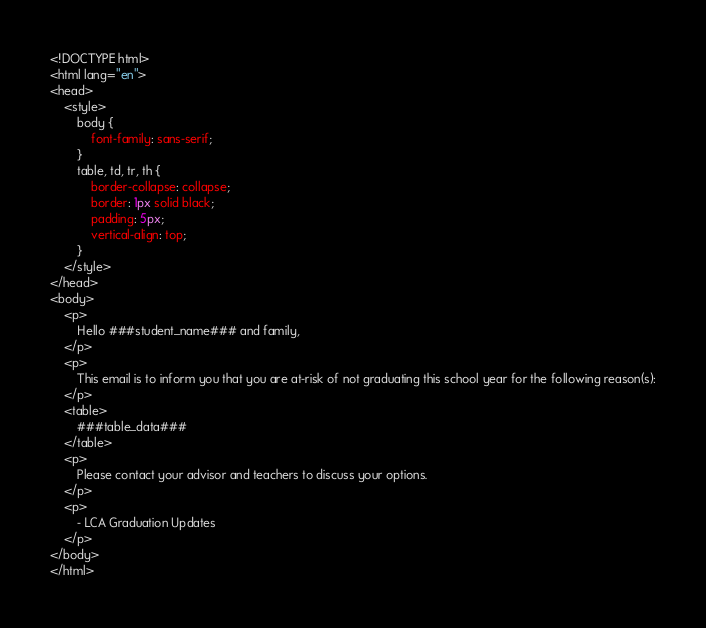Convert code to text. <code><loc_0><loc_0><loc_500><loc_500><_HTML_><!DOCTYPE html>
<html lang="en">
<head>
    <style>
        body {
            font-family: sans-serif;
        }
        table, td, tr, th {
            border-collapse: collapse;
            border: 1px solid black;
            padding: 5px;
            vertical-align: top;
        }
    </style>
</head>
<body>
    <p>
        Hello ###student_name### and family,
    </p>
    <p>
        This email is to inform you that you are at-risk of not graduating this school year for the following reason(s):
    </p>
    <table>
        ###table_data###
    </table>
    <p>
        Please contact your advisor and teachers to discuss your options.
    </p>
    <p>
        - LCA Graduation Updates
    </p>
</body>
</html></code> 